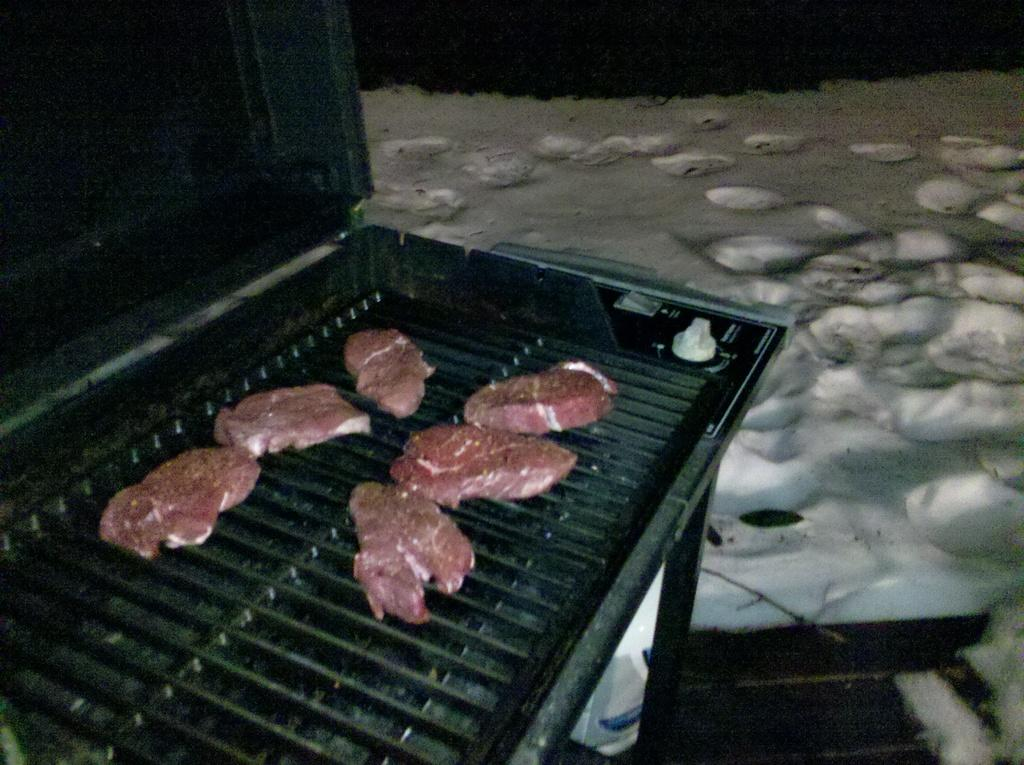What is being cooked or prepared in the image? There is a food item on a grill in the image. What type of surface is visible in the image? There is white-colored sand visible in the image. What type of hat is being worn by the person in the image? There is no person or hat present in the image. What view can be seen from the location in the image? The image does not provide a view or a location from which a view can be seen. 